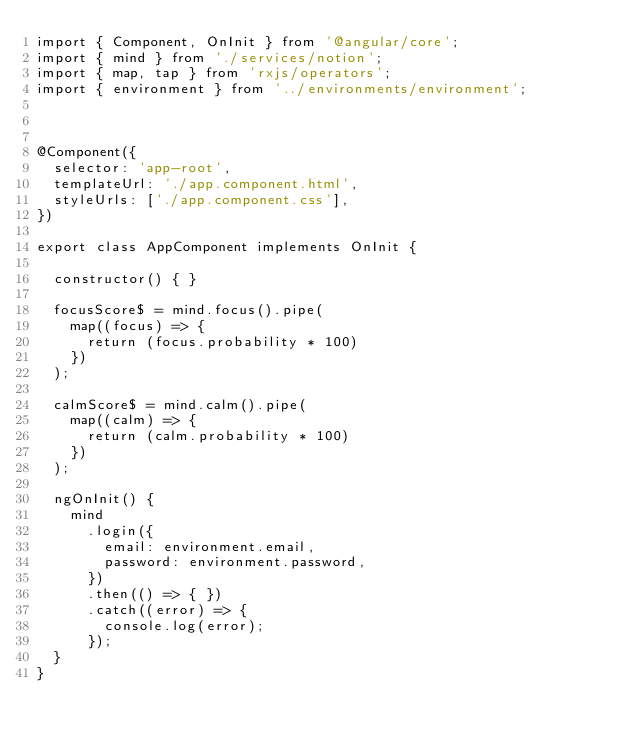<code> <loc_0><loc_0><loc_500><loc_500><_TypeScript_>import { Component, OnInit } from '@angular/core';
import { mind } from './services/notion';
import { map, tap } from 'rxjs/operators';
import { environment } from '../environments/environment';



@Component({
  selector: 'app-root',
  templateUrl: './app.component.html',
  styleUrls: ['./app.component.css'],
})

export class AppComponent implements OnInit {

  constructor() { }

  focusScore$ = mind.focus().pipe(
    map((focus) => {
      return (focus.probability * 100)
    })
  );

  calmScore$ = mind.calm().pipe(
    map((calm) => {
      return (calm.probability * 100)
    })
  );

  ngOnInit() {
    mind
      .login({
        email: environment.email,
        password: environment.password,
      })
      .then(() => { })
      .catch((error) => {
        console.log(error);
      });
  }
}
</code> 